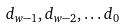<formula> <loc_0><loc_0><loc_500><loc_500>d _ { w - 1 } , d _ { w - 2 } , \dots d _ { 0 }</formula> 